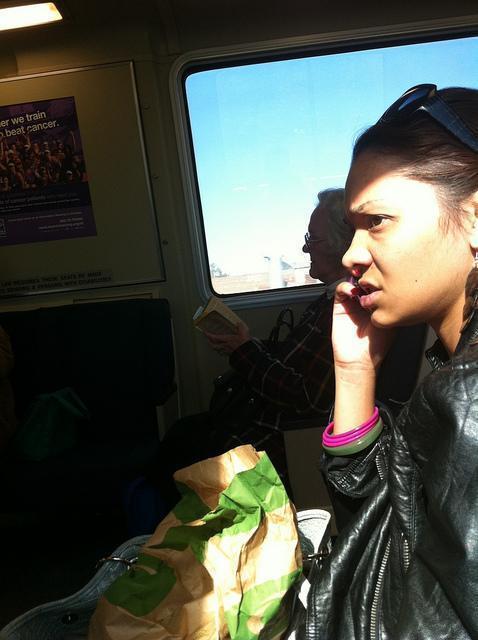What is the brown and green bag made from?
Pick the correct solution from the four options below to address the question.
Options: Rubber, plastic, paper, vinyl. Paper. 